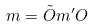<formula> <loc_0><loc_0><loc_500><loc_500>m = \tilde { O } m ^ { \prime } O</formula> 